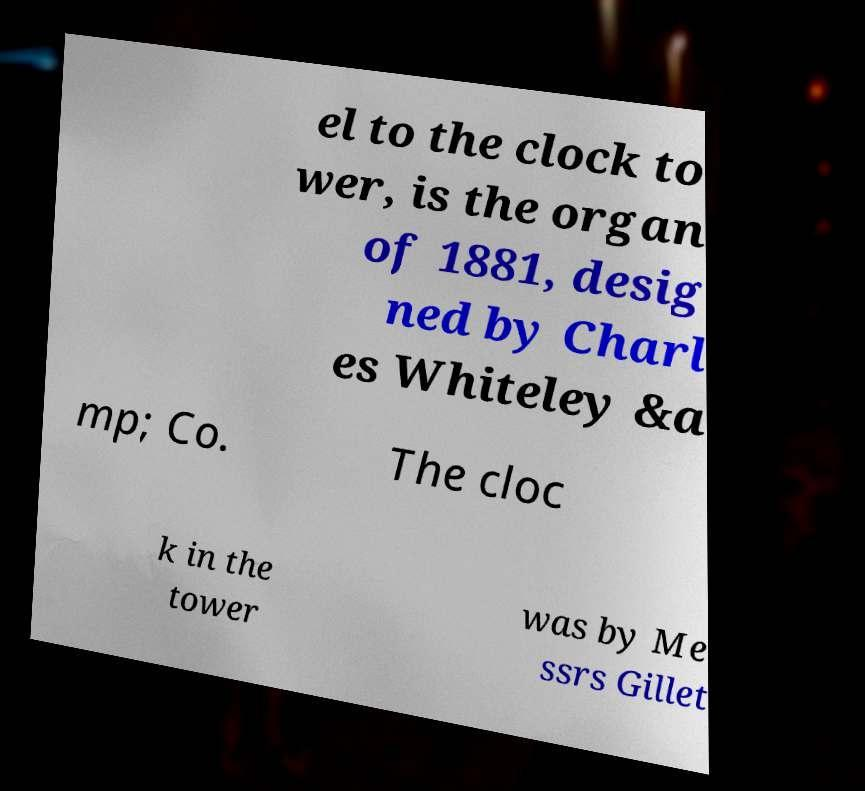Could you extract and type out the text from this image? el to the clock to wer, is the organ of 1881, desig ned by Charl es Whiteley &a mp; Co. The cloc k in the tower was by Me ssrs Gillet 